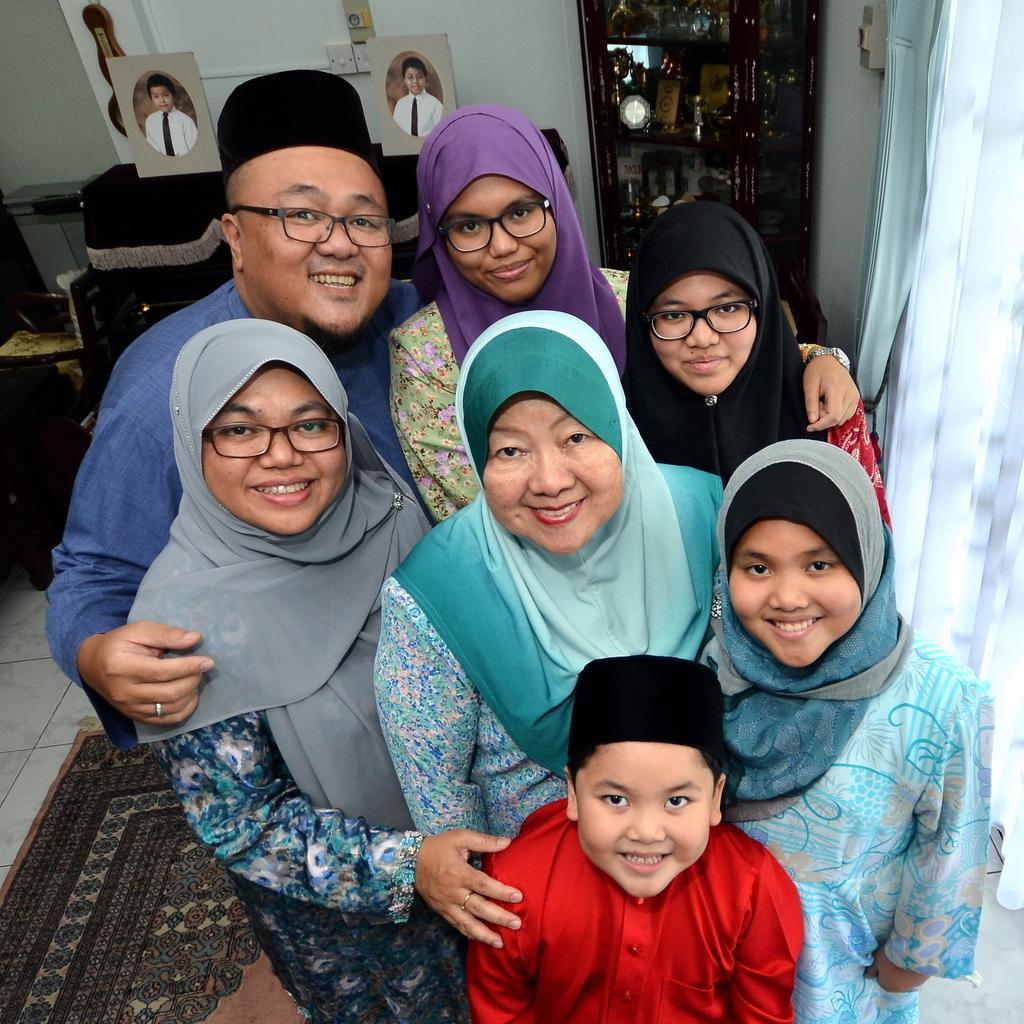In one or two sentences, can you explain what this image depicts? In this image we can see a man, woman, girls and a boy. Right side of the image curtain is there. Background of the image cupboard and photographs are attached to the white color wall. Left bottom of the image carpet is there. 